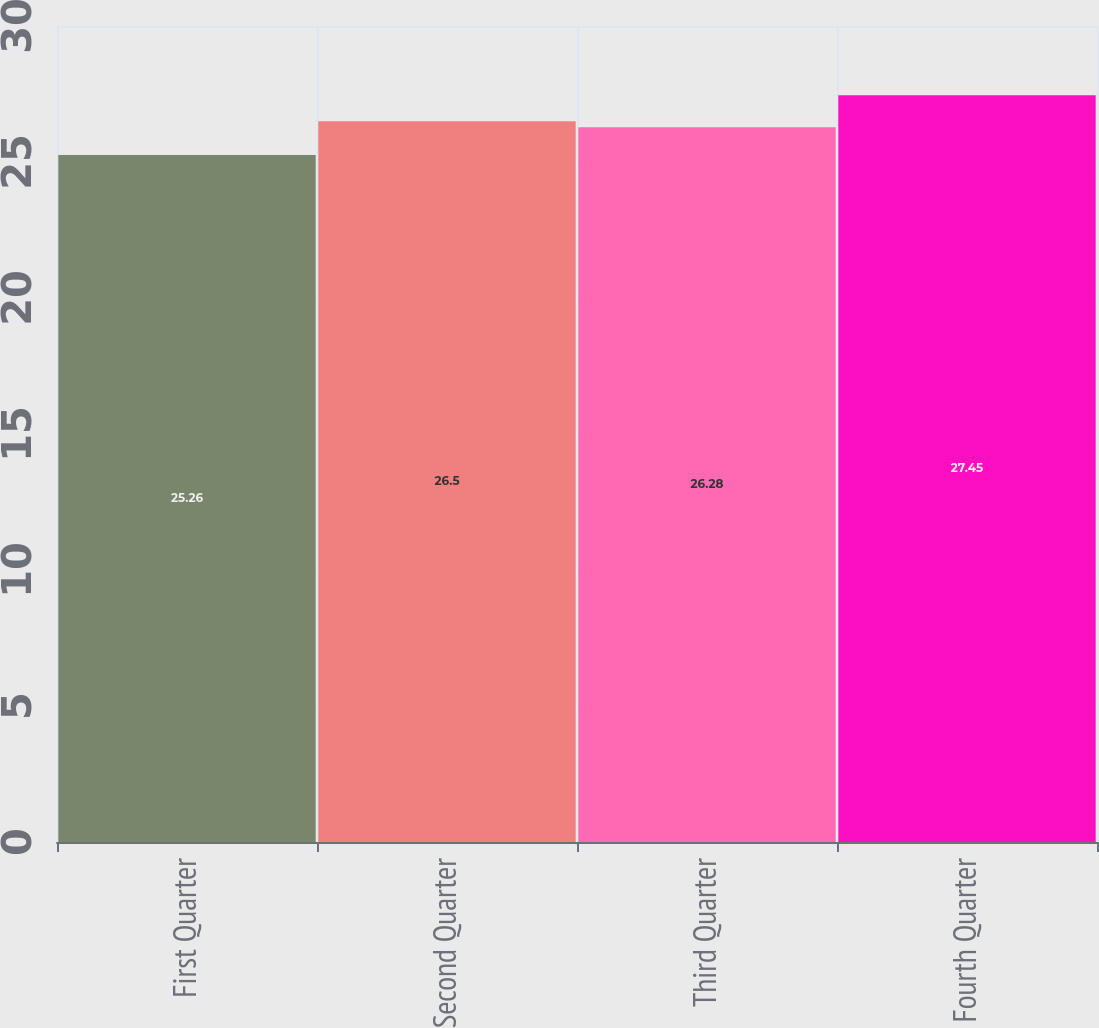Convert chart. <chart><loc_0><loc_0><loc_500><loc_500><bar_chart><fcel>First Quarter<fcel>Second Quarter<fcel>Third Quarter<fcel>Fourth Quarter<nl><fcel>25.26<fcel>26.5<fcel>26.28<fcel>27.45<nl></chart> 